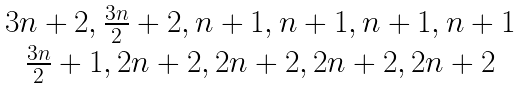<formula> <loc_0><loc_0><loc_500><loc_500>\begin{matrix} { 3 n + 2 , \frac { 3 n } { 2 } + 2 , n + 1 , n + 1 , n + 1 , n + 1 } \\ { \frac { 3 n } { 2 } + 1 , 2 n + 2 , 2 n + 2 , 2 n + 2 , 2 n + 2 } \end{matrix}</formula> 